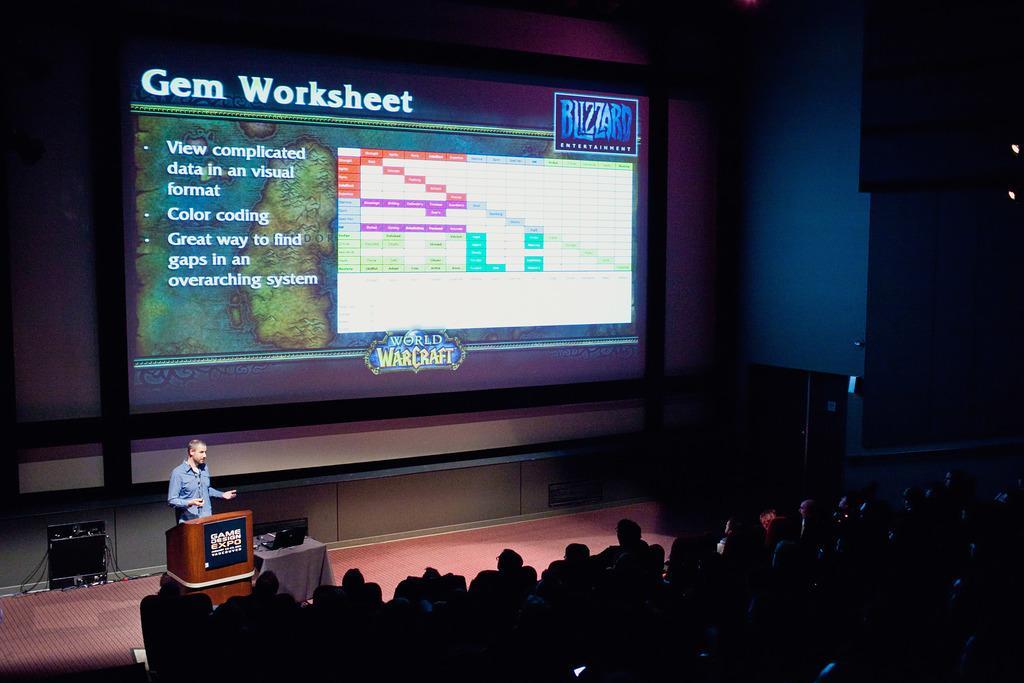Please provide a concise description of this image. In this image we can see a person is standing on the floor. Here we can see a podium, table, cloth, laptop, door, and other objects. At the bottom of the image we can see people are sitting on the chairs. In the background we can see wall, lights, and a screen. 